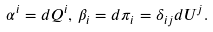<formula> <loc_0><loc_0><loc_500><loc_500>\alpha ^ { i } = d Q ^ { i } , \, \beta _ { i } = d \pi _ { i } = \delta _ { i j } d U ^ { j } .</formula> 